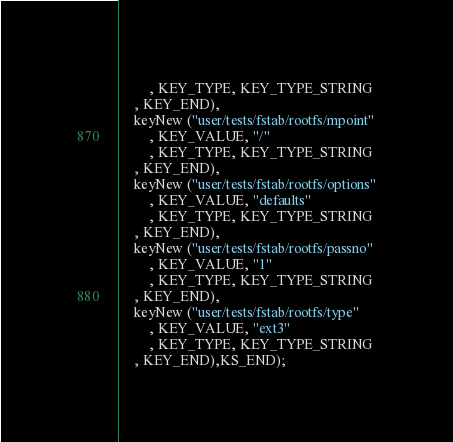Convert code to text. <code><loc_0><loc_0><loc_500><loc_500><_C_>		, KEY_TYPE, KEY_TYPE_STRING
	, KEY_END),
	keyNew ("user/tests/fstab/rootfs/mpoint"
		, KEY_VALUE, "/"
		, KEY_TYPE, KEY_TYPE_STRING
	, KEY_END),
	keyNew ("user/tests/fstab/rootfs/options"
		, KEY_VALUE, "defaults"
		, KEY_TYPE, KEY_TYPE_STRING
	, KEY_END),
	keyNew ("user/tests/fstab/rootfs/passno"
		, KEY_VALUE, "1"
		, KEY_TYPE, KEY_TYPE_STRING
	, KEY_END),
	keyNew ("user/tests/fstab/rootfs/type"
		, KEY_VALUE, "ext3"
		, KEY_TYPE, KEY_TYPE_STRING
	, KEY_END),KS_END);
</code> 